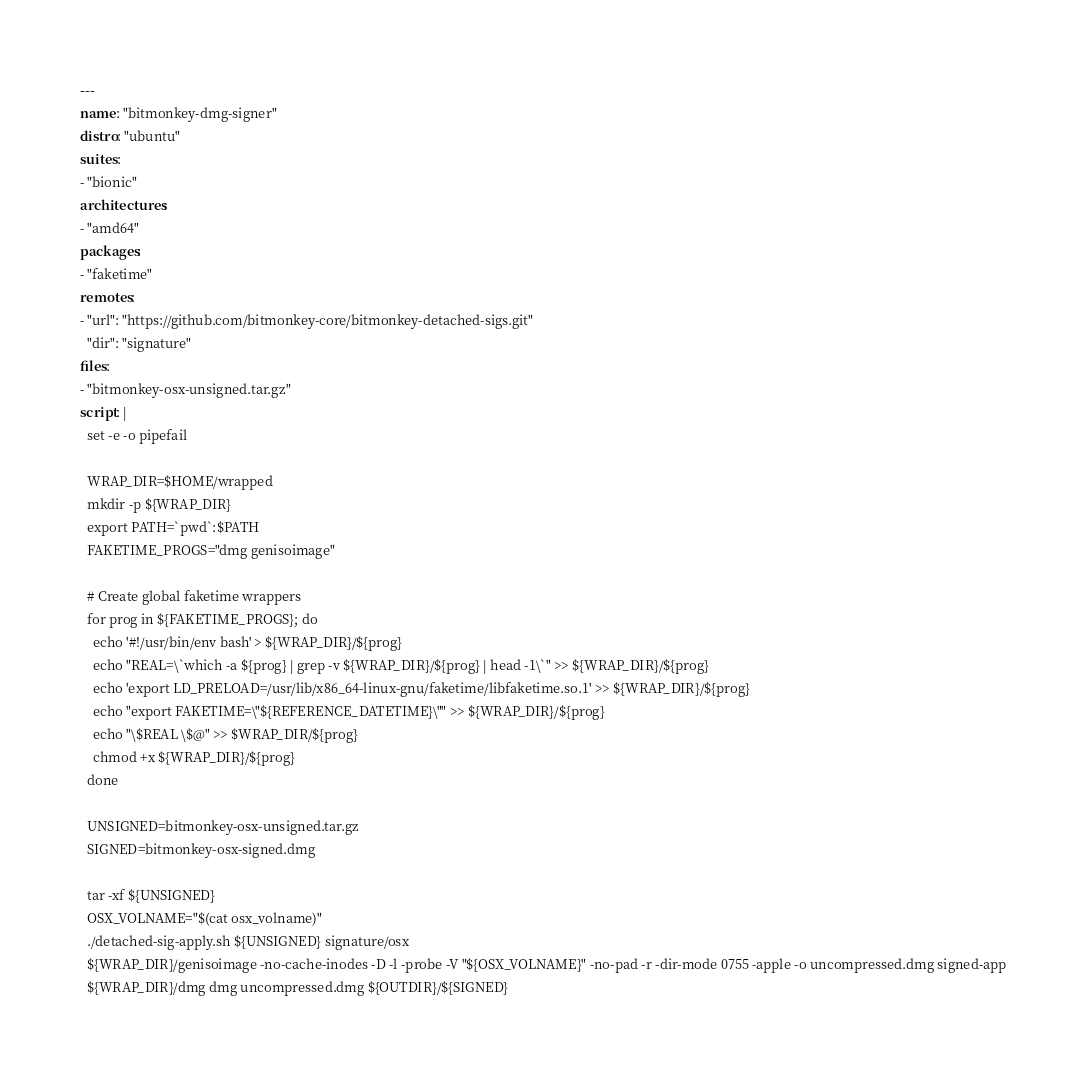Convert code to text. <code><loc_0><loc_0><loc_500><loc_500><_YAML_>---
name: "bitmonkey-dmg-signer"
distro: "ubuntu"
suites:
- "bionic"
architectures:
- "amd64"
packages:
- "faketime"
remotes:
- "url": "https://github.com/bitmonkey-core/bitmonkey-detached-sigs.git"
  "dir": "signature"
files:
- "bitmonkey-osx-unsigned.tar.gz"
script: |
  set -e -o pipefail

  WRAP_DIR=$HOME/wrapped
  mkdir -p ${WRAP_DIR}
  export PATH=`pwd`:$PATH
  FAKETIME_PROGS="dmg genisoimage"

  # Create global faketime wrappers
  for prog in ${FAKETIME_PROGS}; do
    echo '#!/usr/bin/env bash' > ${WRAP_DIR}/${prog}
    echo "REAL=\`which -a ${prog} | grep -v ${WRAP_DIR}/${prog} | head -1\`" >> ${WRAP_DIR}/${prog}
    echo 'export LD_PRELOAD=/usr/lib/x86_64-linux-gnu/faketime/libfaketime.so.1' >> ${WRAP_DIR}/${prog}
    echo "export FAKETIME=\"${REFERENCE_DATETIME}\"" >> ${WRAP_DIR}/${prog}
    echo "\$REAL \$@" >> $WRAP_DIR/${prog}
    chmod +x ${WRAP_DIR}/${prog}
  done

  UNSIGNED=bitmonkey-osx-unsigned.tar.gz
  SIGNED=bitmonkey-osx-signed.dmg

  tar -xf ${UNSIGNED}
  OSX_VOLNAME="$(cat osx_volname)"
  ./detached-sig-apply.sh ${UNSIGNED} signature/osx
  ${WRAP_DIR}/genisoimage -no-cache-inodes -D -l -probe -V "${OSX_VOLNAME}" -no-pad -r -dir-mode 0755 -apple -o uncompressed.dmg signed-app
  ${WRAP_DIR}/dmg dmg uncompressed.dmg ${OUTDIR}/${SIGNED}
</code> 